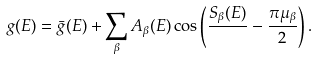<formula> <loc_0><loc_0><loc_500><loc_500>g ( E ) = \bar { g } ( E ) + \sum _ { \beta } A _ { \beta } ( E ) \cos \left ( \frac { S _ { \beta } ( E ) } { } - \frac { \pi \mu _ { \beta } } { 2 } \right ) .</formula> 